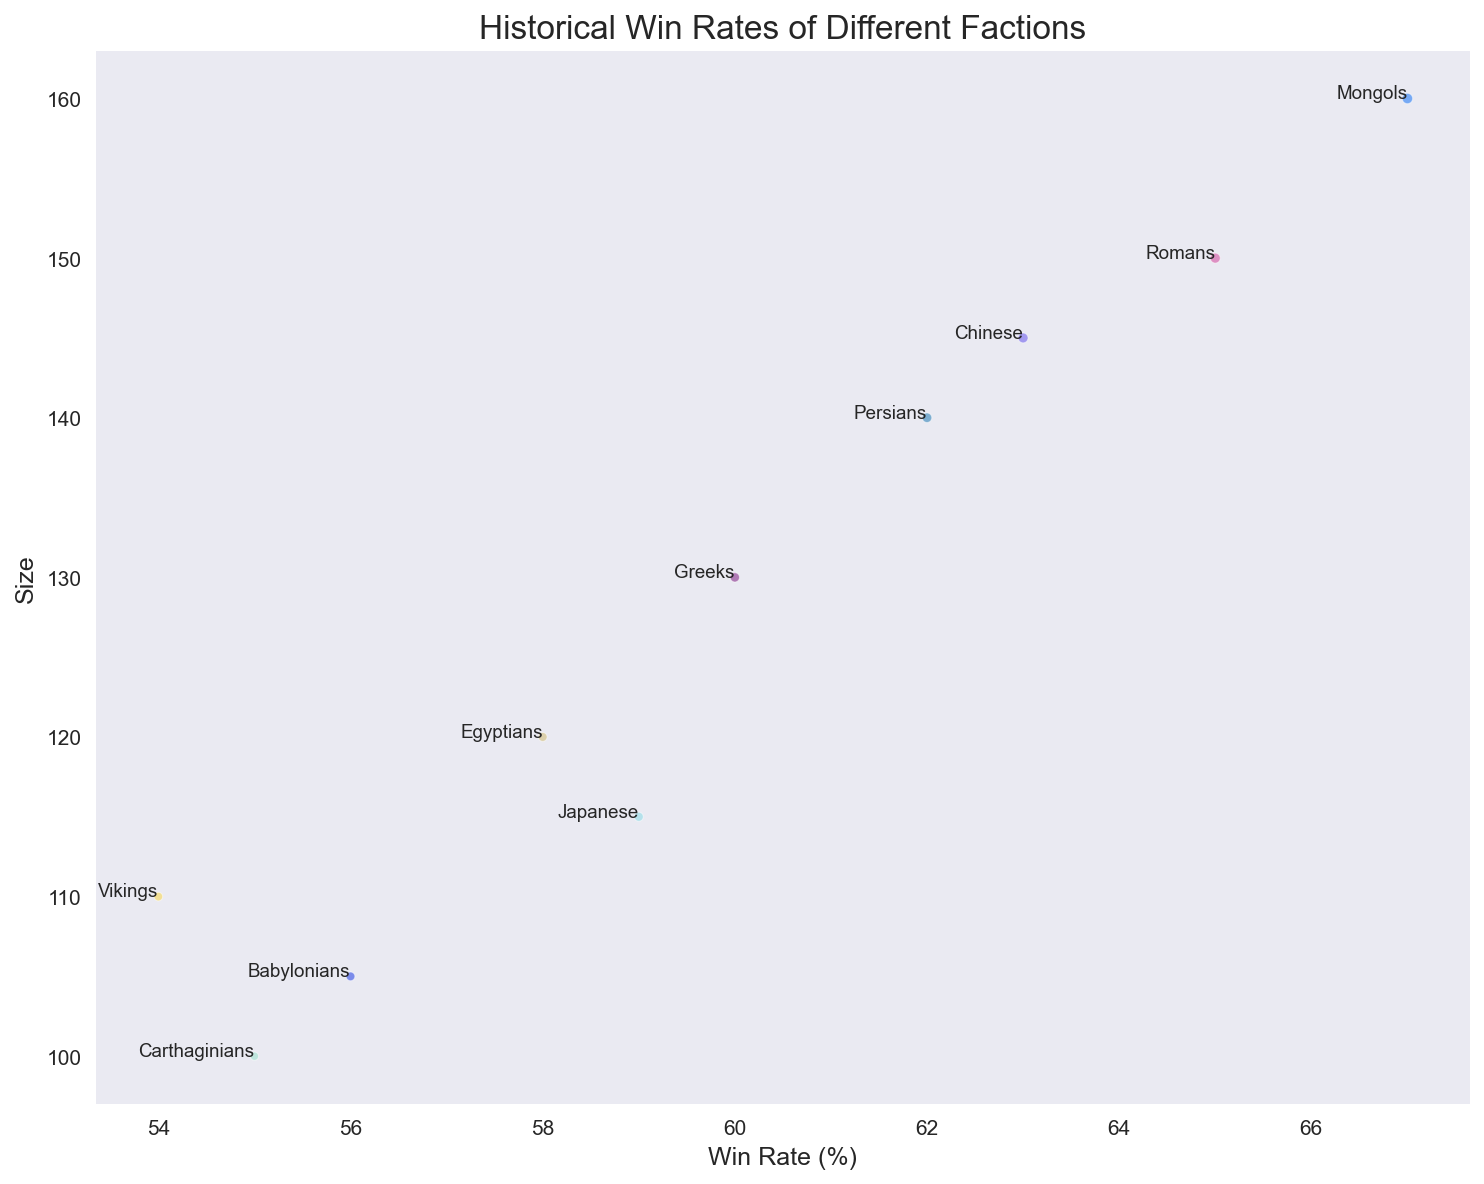What's the faction with the highest win rate? To determine the faction with the highest win rate, look at the x-axis (Win Rate) and find the furthest point to the right. From the chart, the Mongols have a Win Rate of 67%, which is the highest.
Answer: Mongols Which faction has the smallest size and what is its win rate? Identify the faction with the smallest value on the y-axis (Size). The Carthaginians have the smallest size of 100. Then, check the corresponding Win Rate on the x-axis, which is 55%.
Answer: Carthaginians, 55% Compare the win rates of the Romans and Greeks. Which one is higher and by how much? Locate the Romans and Greeks on the x-axis (Win Rate). The Romans have a Win Rate of 65%, and the Greeks have a Win Rate of 60%. The difference is 65 - 60 = 5%.
Answer: Romans by 5% Which faction has the second largest battle count and what is its size? To find the second largest battle count, compare the size of the bubbles. The largest battle count bubble is the Mongols, with 250 battles. The second largest is the Romans with 230 battles. The size of the Romans is 150.
Answer: Romans, 150 What's the average size of all factions? Sum all the size values and divide by the number of factions. (150 + 130 + 120 + 140 + 100 + 160 + 110 + 115 + 105 + 145) / 10 = 127.5
Answer: 127.5 Which faction has a lower win rate than the Babylonians but a higher size? Find factions with a win rate lower than 56% (Babylonians) and compare their sizes to 105. The Carthaginians have a Win Rate of 55% and a size of 100, which is not higher. The only faction that fits the criteria is the Vikings with a Win Rate of 54% and a size of 110.
Answer: Vikings Which faction has the largest bubble and what does it represent? Locate the largest bubble on the plot. The Mongols have the largest bubble which represents their battle count. The bubble size correlates to 250 battles.
Answer: Mongols, Battle Count If you sum the win rates of the Japanese and Chinese factions, what value do you get? Find the Win Rates for the Japanese (59%) and the Chinese (63%) and add them together. 59 + 63 = 122.
Answer: 122 